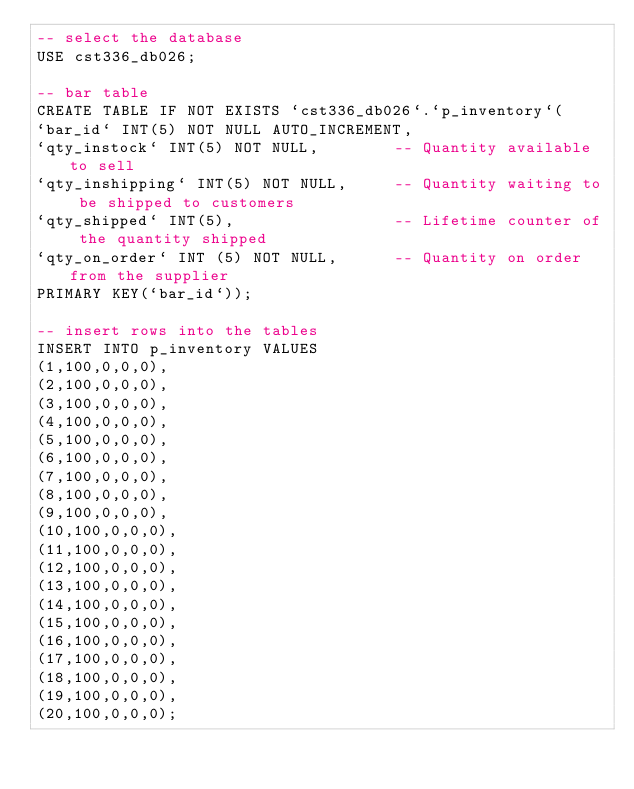Convert code to text. <code><loc_0><loc_0><loc_500><loc_500><_SQL_>-- select the database
USE cst336_db026;

-- bar table
CREATE TABLE IF NOT EXISTS `cst336_db026`.`p_inventory`(
`bar_id` INT(5) NOT NULL AUTO_INCREMENT,
`qty_instock` INT(5) NOT NULL,        -- Quantity available to sell
`qty_inshipping` INT(5) NOT NULL,     -- Quantity waiting to be shipped to customers
`qty_shipped` INT(5),                 -- Lifetime counter of the quantity shipped
`qty_on_order` INT (5) NOT NULL,      -- Quantity on order from the supplier
PRIMARY KEY(`bar_id`));

-- insert rows into the tables
INSERT INTO p_inventory VALUES
(1,100,0,0,0), 
(2,100,0,0,0), 
(3,100,0,0,0), 
(4,100,0,0,0), 
(5,100,0,0,0), 
(6,100,0,0,0), 
(7,100,0,0,0), 
(8,100,0,0,0), 
(9,100,0,0,0), 
(10,100,0,0,0), 
(11,100,0,0,0), 
(12,100,0,0,0), 
(13,100,0,0,0), 
(14,100,0,0,0), 
(15,100,0,0,0),
(16,100,0,0,0),
(17,100,0,0,0),
(18,100,0,0,0),
(19,100,0,0,0),
(20,100,0,0,0);
</code> 